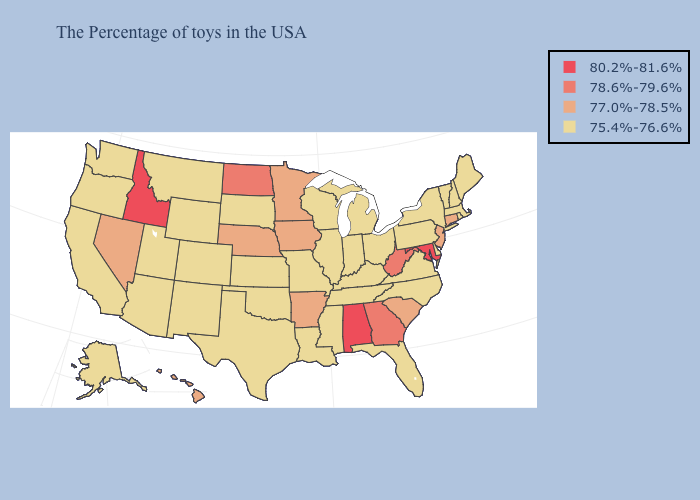What is the highest value in states that border Wisconsin?
Keep it brief. 77.0%-78.5%. What is the value of Wyoming?
Concise answer only. 75.4%-76.6%. What is the lowest value in the MidWest?
Answer briefly. 75.4%-76.6%. Among the states that border Delaware , does Pennsylvania have the highest value?
Short answer required. No. What is the value of Colorado?
Keep it brief. 75.4%-76.6%. Does Wyoming have the highest value in the West?
Answer briefly. No. Name the states that have a value in the range 75.4%-76.6%?
Be succinct. Maine, Massachusetts, Rhode Island, New Hampshire, Vermont, New York, Delaware, Pennsylvania, Virginia, North Carolina, Ohio, Florida, Michigan, Kentucky, Indiana, Tennessee, Wisconsin, Illinois, Mississippi, Louisiana, Missouri, Kansas, Oklahoma, Texas, South Dakota, Wyoming, Colorado, New Mexico, Utah, Montana, Arizona, California, Washington, Oregon, Alaska. Does Washington have the highest value in the USA?
Concise answer only. No. What is the lowest value in the West?
Be succinct. 75.4%-76.6%. Name the states that have a value in the range 75.4%-76.6%?
Concise answer only. Maine, Massachusetts, Rhode Island, New Hampshire, Vermont, New York, Delaware, Pennsylvania, Virginia, North Carolina, Ohio, Florida, Michigan, Kentucky, Indiana, Tennessee, Wisconsin, Illinois, Mississippi, Louisiana, Missouri, Kansas, Oklahoma, Texas, South Dakota, Wyoming, Colorado, New Mexico, Utah, Montana, Arizona, California, Washington, Oregon, Alaska. Does Idaho have the highest value in the USA?
Write a very short answer. Yes. What is the value of Indiana?
Answer briefly. 75.4%-76.6%. Name the states that have a value in the range 75.4%-76.6%?
Keep it brief. Maine, Massachusetts, Rhode Island, New Hampshire, Vermont, New York, Delaware, Pennsylvania, Virginia, North Carolina, Ohio, Florida, Michigan, Kentucky, Indiana, Tennessee, Wisconsin, Illinois, Mississippi, Louisiana, Missouri, Kansas, Oklahoma, Texas, South Dakota, Wyoming, Colorado, New Mexico, Utah, Montana, Arizona, California, Washington, Oregon, Alaska. Name the states that have a value in the range 78.6%-79.6%?
Write a very short answer. West Virginia, Georgia, North Dakota. 